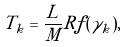Convert formula to latex. <formula><loc_0><loc_0><loc_500><loc_500>T _ { k } = \frac { L } { M } R f ( \gamma _ { k } ) ,</formula> 